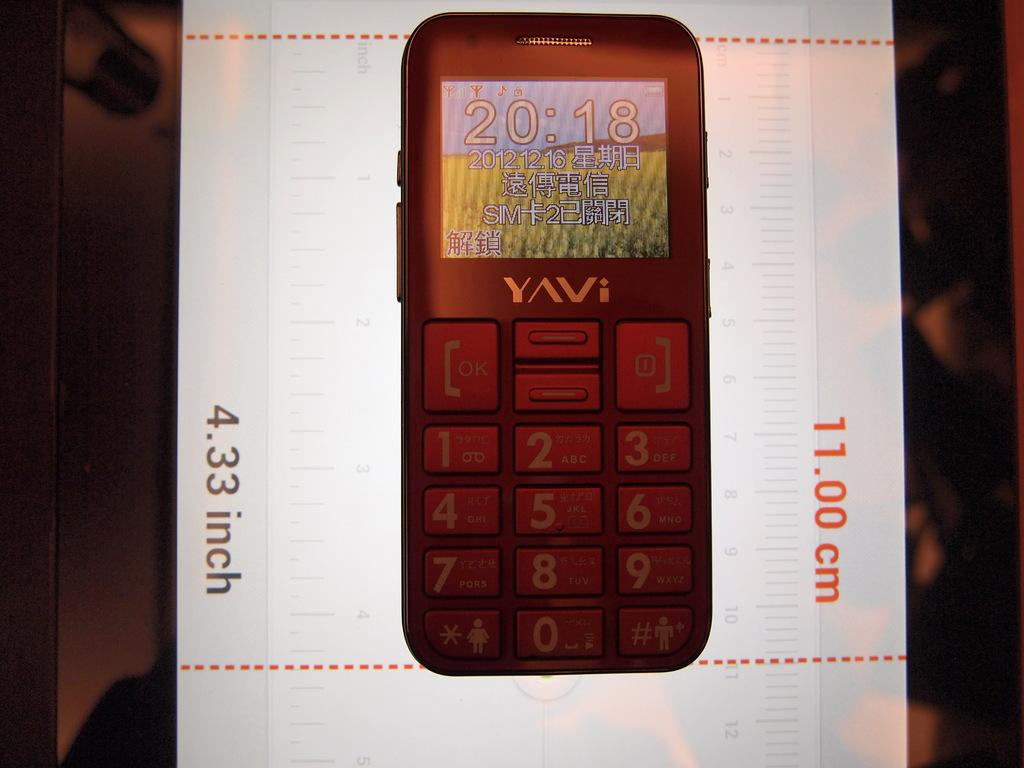<image>
Share a concise interpretation of the image provided. The box for the Yavi phone shows that it is 4.33 inches 